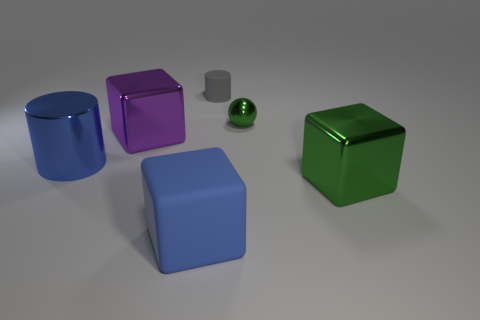Are there any indications in the image that suggest relative sizes of these objects? While there's a lack of familiar objects that would provide a precise scale, the shadows and proximity of the objects suggest they have similar sizes, likely comparable to small household items. 